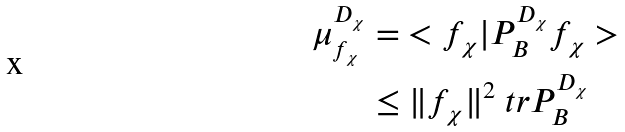Convert formula to latex. <formula><loc_0><loc_0><loc_500><loc_500>\mu _ { f _ { \chi } } ^ { D _ { \chi } } & = \ < f _ { \chi } | P _ { B } ^ { D _ { \chi } } f _ { \chi } > \\ & \leq \| f _ { \chi } \| ^ { 2 } \ t r P _ { B } ^ { D _ { \chi } }</formula> 